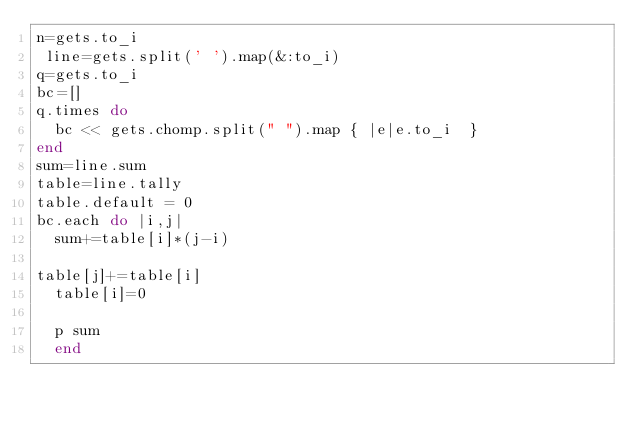<code> <loc_0><loc_0><loc_500><loc_500><_Ruby_>n=gets.to_i
 line=gets.split(' ').map(&:to_i)
q=gets.to_i
bc=[]
q.times do
  bc << gets.chomp.split(" ").map { |e|e.to_i  }
end
sum=line.sum
table=line.tally
table.default = 0
bc.each do |i,j|
  sum+=table[i]*(j-i)

table[j]+=table[i]
  table[i]=0

  p sum
  end

 
</code> 